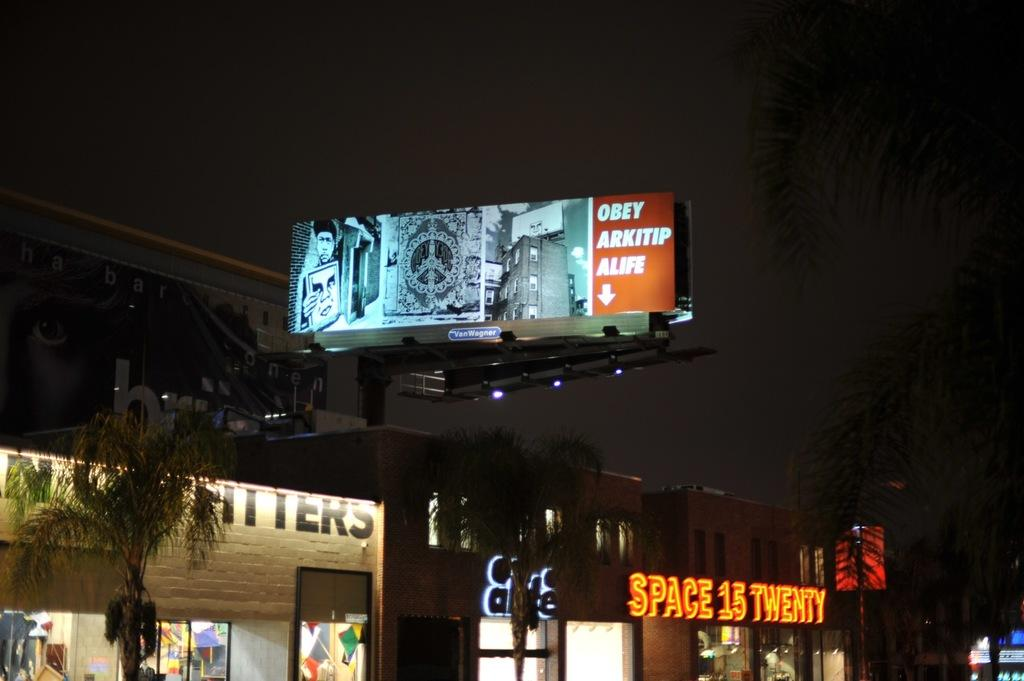<image>
Write a terse but informative summary of the picture. A shop titled Space 15 Twenty sitting under a billboard at night. 